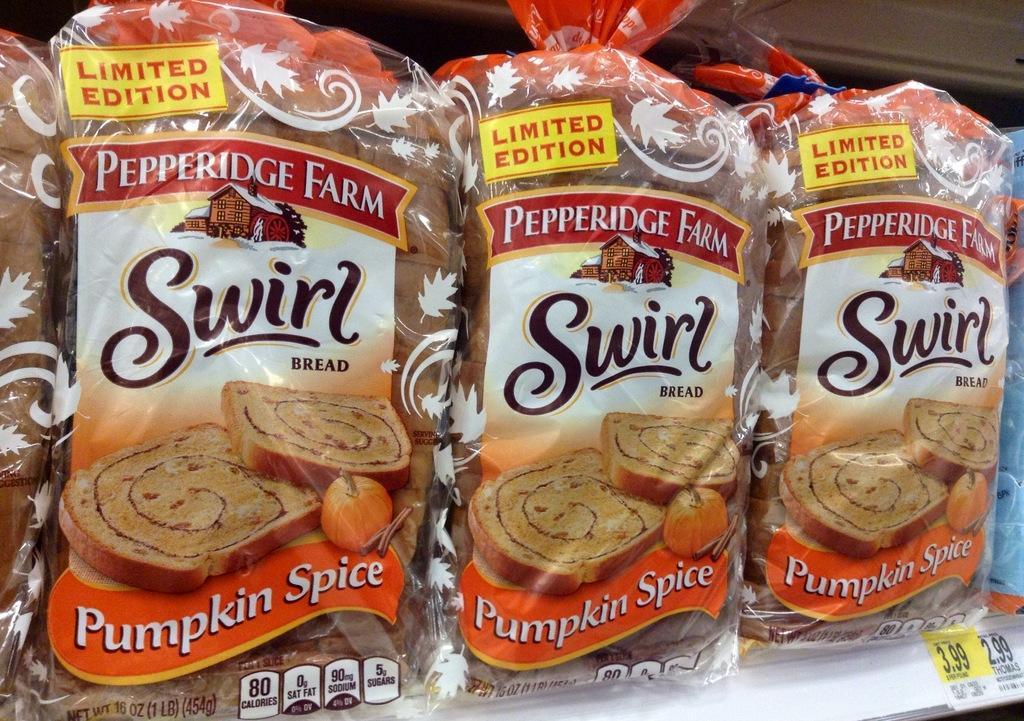Could you give a brief overview of what you see in this image? In this image there are food packets and stickers. Something is written on the food packets and stickers. 